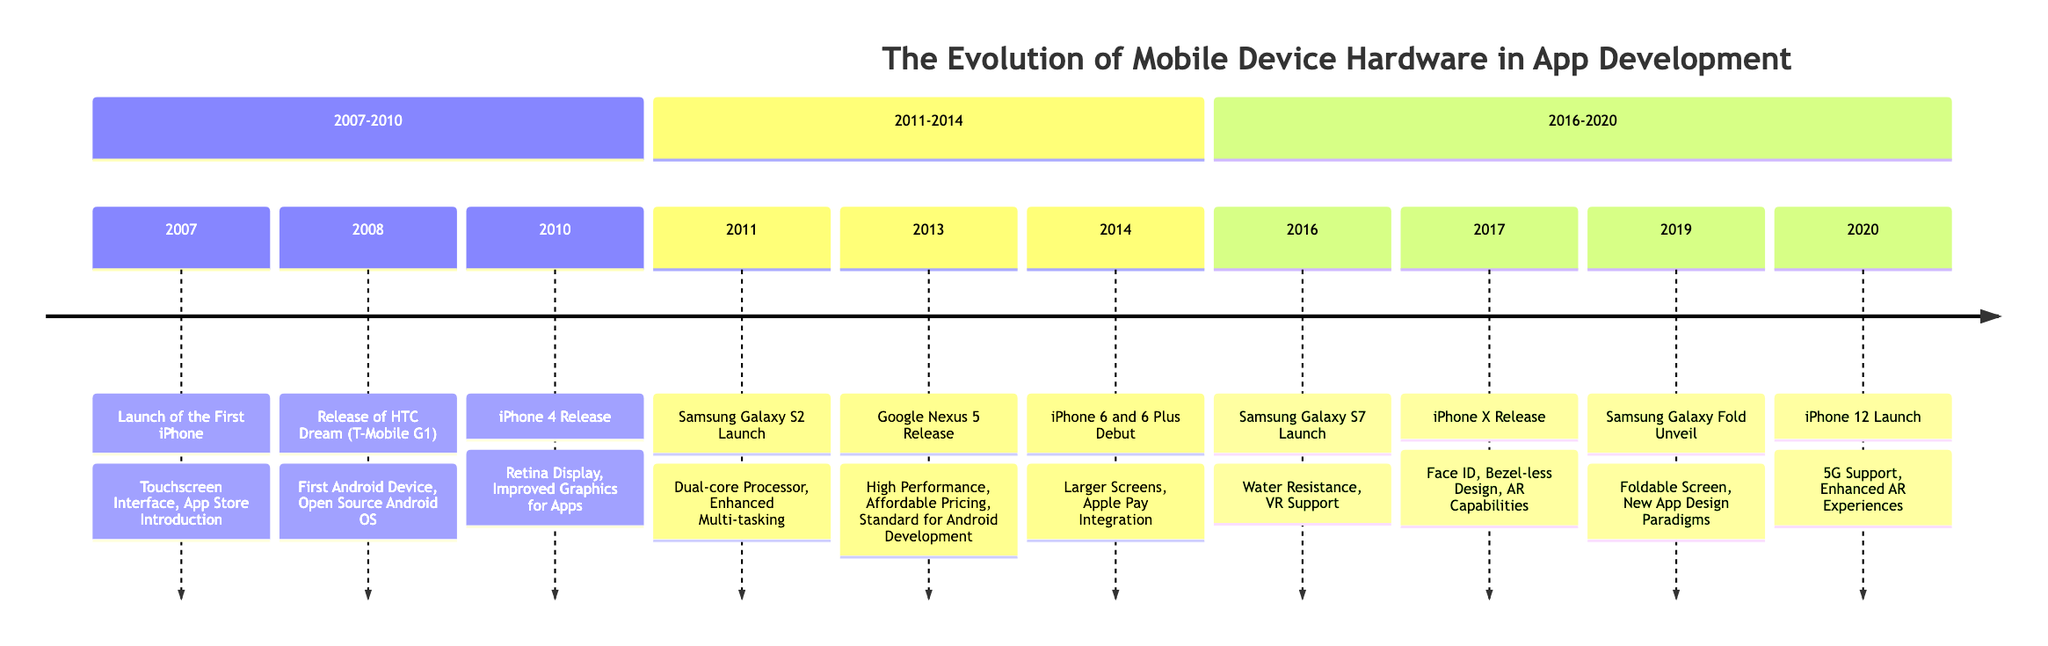What year was the first iPhone launched? The diagram indicates the event "Launch of the First iPhone" in the year 2007
Answer: 2007 What impact did the iPhone 4 have on app development? For the iPhone 4 released in 2010, the impact was listed as "Retina Display, Improved Graphics for Apps," which indicates improvements in visual quality for applications
Answer: Retina Display, Improved Graphics for Apps How many major smartphone releases are mentioned in the timeline? By counting each event listed in the timeline, there are a total of 10 notable smartphone releases highlighted
Answer: 10 Which smartphone introduced the bezel-less design? The diagram shows that the "iPhone X Release" in 2017 was the event that introduced "Bezel-less Design, Augmented Reality (AR) Capabilities," indicating it was a key feature of this phone
Answer: iPhone X What is the flavor of tea associated with the Samsung Galaxy Fold's unveiling? According to the timeline, the flavor of tea paired with the "Samsung Galaxy Fold Unveil" in 2019 is "Hibiscus"
Answer: Hibiscus Which device marked the introduction of 5G support? The timeline notes that the "iPhone 12 Launch" in 2020 is where "5G Support, Enhanced AR Experiences" were introduced, making it the device that marked this significant advancement
Answer: iPhone 12 What was a significant feature of the HTC Dream? The diagram indicates that the event "Release of HTC Dream (T-Mobile G1)" in 2008 highlighted "First Android Device, Open Source Android OS," which signifies its significance in mobile operating systems
Answer: First Android Device, Open Source Android OS What notable hardware advancement did the Samsung Galaxy S2 introduce? The "Samsung Galaxy S2 Launch" in 2011 is shown to have introduced a "Dual-core Processor, Enhanced Multi-tasking," marking a substantial improvement in processing capabilities
Answer: Dual-core Processor, Enhanced Multi-tasking Which smartphone had an emphasis on water resistance? The timeline states that the "Samsung Galaxy S7 Launch" in 2016 had the impact of "Water Resistance, VR Support," thus emphasizing its durability features
Answer: Samsung Galaxy S7 